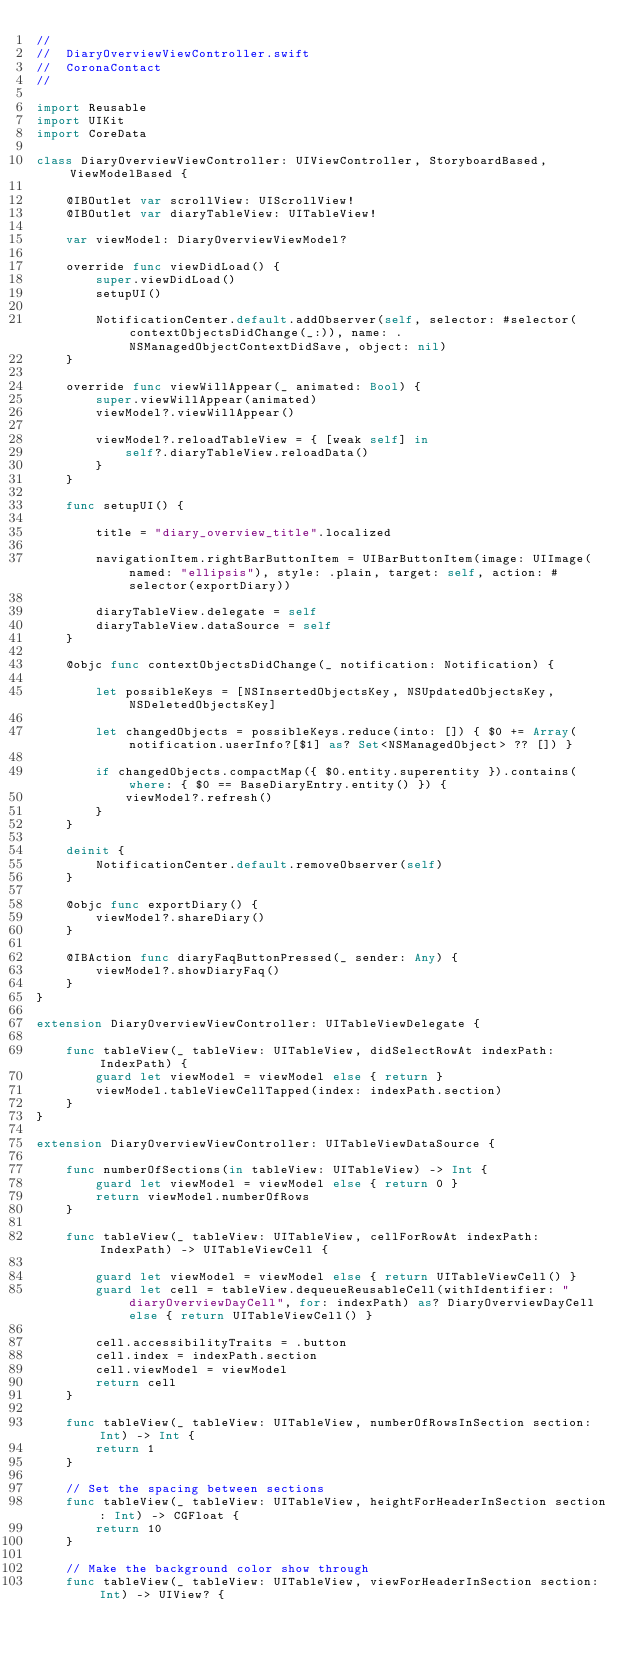<code> <loc_0><loc_0><loc_500><loc_500><_Swift_>//
//  DiaryOverviewViewController.swift
//  CoronaContact
//

import Reusable
import UIKit
import CoreData

class DiaryOverviewViewController: UIViewController, StoryboardBased, ViewModelBased {
    
    @IBOutlet var scrollView: UIScrollView!
    @IBOutlet var diaryTableView: UITableView!
    
    var viewModel: DiaryOverviewViewModel?
    
    override func viewDidLoad() {
        super.viewDidLoad()
        setupUI()
        
        NotificationCenter.default.addObserver(self, selector: #selector(contextObjectsDidChange(_:)), name: .NSManagedObjectContextDidSave, object: nil)
    }
    
    override func viewWillAppear(_ animated: Bool) {
        super.viewWillAppear(animated)
        viewModel?.viewWillAppear()
        
        viewModel?.reloadTableView = { [weak self] in
            self?.diaryTableView.reloadData()
        }
    }
    
    func setupUI() {
        
        title = "diary_overview_title".localized
        
        navigationItem.rightBarButtonItem = UIBarButtonItem(image: UIImage(named: "ellipsis"), style: .plain, target: self, action: #selector(exportDiary))
        
        diaryTableView.delegate = self
        diaryTableView.dataSource = self
    }
    
    @objc func contextObjectsDidChange(_ notification: Notification) {
        
        let possibleKeys = [NSInsertedObjectsKey, NSUpdatedObjectsKey, NSDeletedObjectsKey]
        
        let changedObjects = possibleKeys.reduce(into: []) { $0 += Array(notification.userInfo?[$1] as? Set<NSManagedObject> ?? []) }
        
        if changedObjects.compactMap({ $0.entity.superentity }).contains(where: { $0 == BaseDiaryEntry.entity() }) {
            viewModel?.refresh()
        }
    }
    
    deinit {
        NotificationCenter.default.removeObserver(self)
    }
    
    @objc func exportDiary() {
        viewModel?.shareDiary()
    }
    
    @IBAction func diaryFaqButtonPressed(_ sender: Any) {
        viewModel?.showDiaryFaq()
    }
}

extension DiaryOverviewViewController: UITableViewDelegate {
    
    func tableView(_ tableView: UITableView, didSelectRowAt indexPath: IndexPath) {
        guard let viewModel = viewModel else { return }
        viewModel.tableViewCellTapped(index: indexPath.section)
    }
}

extension DiaryOverviewViewController: UITableViewDataSource {
    
    func numberOfSections(in tableView: UITableView) -> Int {
        guard let viewModel = viewModel else { return 0 }
        return viewModel.numberOfRows
    }
    
    func tableView(_ tableView: UITableView, cellForRowAt indexPath: IndexPath) -> UITableViewCell {
        
        guard let viewModel = viewModel else { return UITableViewCell() }
        guard let cell = tableView.dequeueReusableCell(withIdentifier: "diaryOverviewDayCell", for: indexPath) as? DiaryOverviewDayCell else { return UITableViewCell() }

        cell.accessibilityTraits = .button
        cell.index = indexPath.section
        cell.viewModel = viewModel
        return cell
    }
    
    func tableView(_ tableView: UITableView, numberOfRowsInSection section: Int) -> Int {
        return 1
    }
    
    // Set the spacing between sections
    func tableView(_ tableView: UITableView, heightForHeaderInSection section: Int) -> CGFloat {
        return 10
    }
    
    // Make the background color show through
    func tableView(_ tableView: UITableView, viewForHeaderInSection section: Int) -> UIView? {</code> 